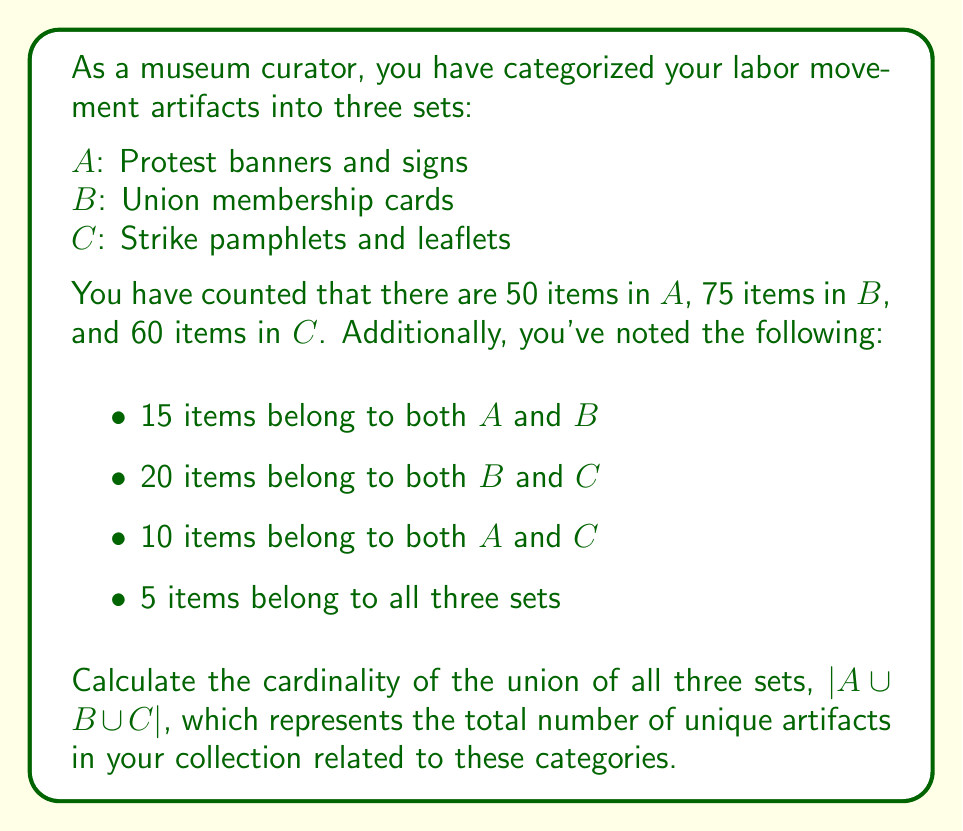Teach me how to tackle this problem. To solve this problem, we'll use the Inclusion-Exclusion Principle for three sets:

$$|A \cup B \cup C| = |A| + |B| + |C| - |A \cap B| - |B \cap C| - |A \cap C| + |A \cap B \cap C|$$

Let's substitute the given values:

1) $|A| = 50$, $|B| = 75$, $|C| = 60$
2) $|A \cap B| = 15$, $|B \cap C| = 20$, $|A \cap C| = 10$
3) $|A \cap B \cap C| = 5$

Now, let's calculate:

$$\begin{align*}
|A \cup B \cup C| &= 50 + 75 + 60 - 15 - 20 - 10 + 5 \\
&= 185 - 45 + 5 \\
&= 145
\end{align*}$$

This result represents the total number of unique artifacts in the collection across these three categories, accounting for items that belong to multiple categories.
Answer: The cardinality of the union of all three sets, $|A \cup B \cup C|$, is 145. 